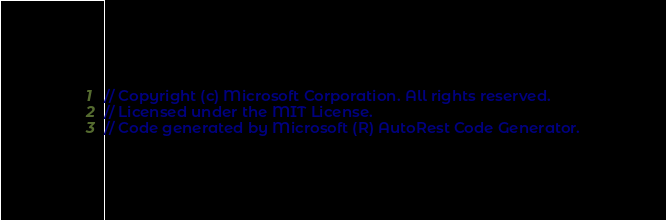Convert code to text. <code><loc_0><loc_0><loc_500><loc_500><_Java_>// Copyright (c) Microsoft Corporation. All rights reserved.
// Licensed under the MIT License.
// Code generated by Microsoft (R) AutoRest Code Generator.</code> 